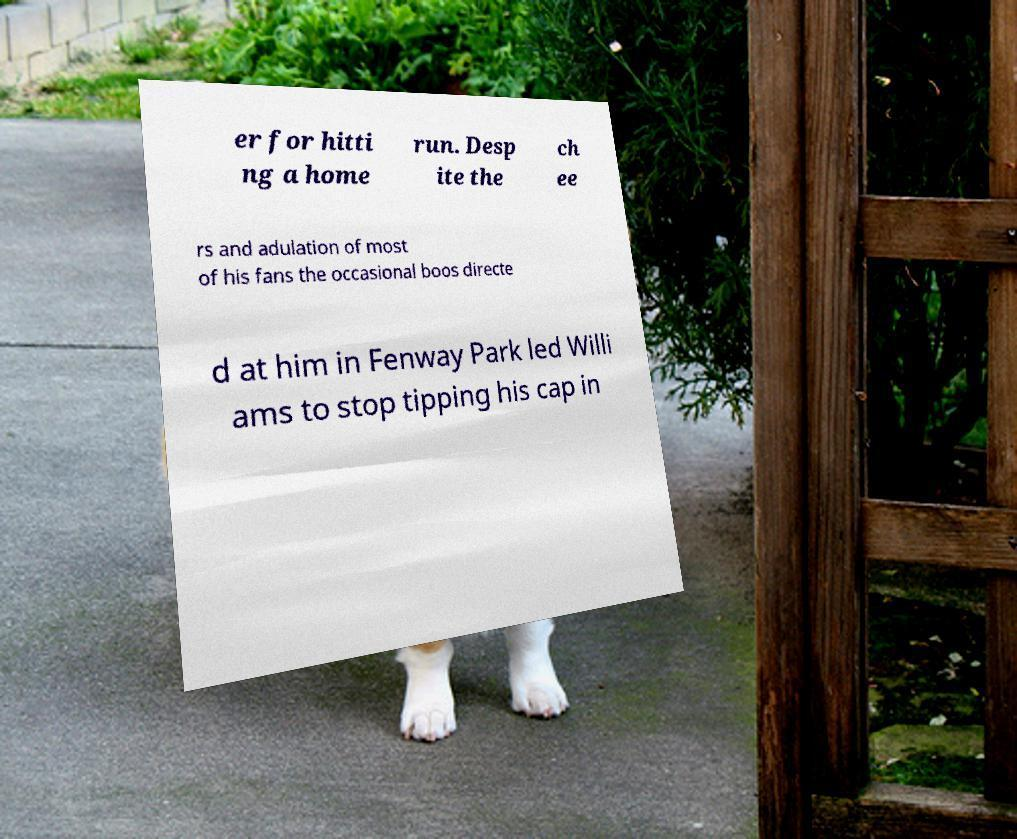For documentation purposes, I need the text within this image transcribed. Could you provide that? er for hitti ng a home run. Desp ite the ch ee rs and adulation of most of his fans the occasional boos directe d at him in Fenway Park led Willi ams to stop tipping his cap in 